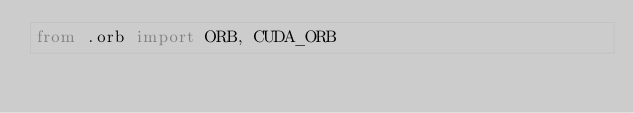Convert code to text. <code><loc_0><loc_0><loc_500><loc_500><_Python_>from .orb import ORB, CUDA_ORB
</code> 